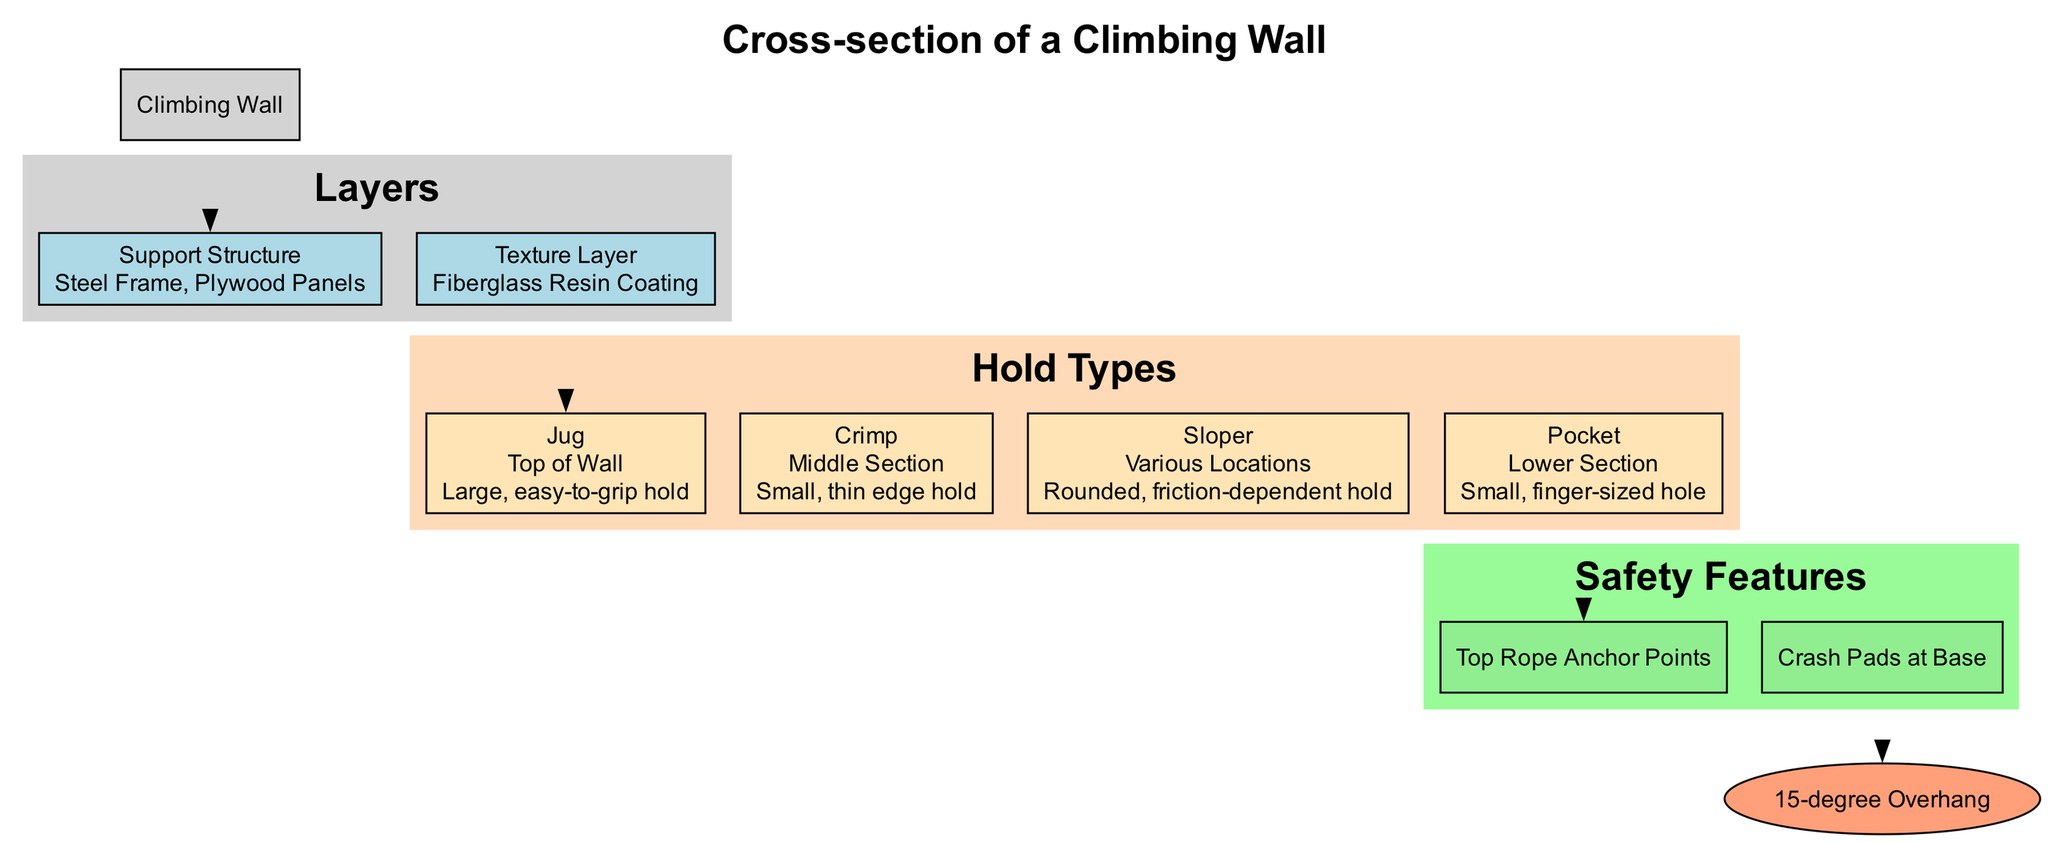What is the main structure of the diagram? The main structure labeled in the diagram is "Climbing Wall." It is represented at the top as the central node which branches out to other components like layers, hold types, and safety features.
Answer: Climbing Wall How many types of climbing holds are there? There are four types of climbing holds indicated in the diagram: Jug, Crimp, Sloper, and Pocket. Each is represented as a separate node under the "Hold Types" section.
Answer: Four What is placed at the top of the climbing wall? The diagram indicates that the type of hold placed at the top of the climbing wall is a "Jug." This is specifically stated in the placement of the Jug hold node.
Answer: Jug Which safety feature is located at the base of the wall? The safety feature shown at the base of the wall in the diagram is "Crash Pads at Base," which is included in the "Safety Features" section.
Answer: Crash Pads at Base What type of hold is described as "rounded, friction-dependent hold"? The hold described with that characteristics is a "Sloper," which is specifically noted in the node detailing the hold types.
Answer: Sloper Where are pocket holds positioned on the wall? According to the diagram, pocket holds are positioned in the "Lower Section" of the climbing wall, as mentioned in the placement description of the Pocket hold node.
Answer: Lower Section What angle does the climbing wall have? The angle of the climbing wall is displayed as "15-degree Overhang." This information is located in the corresponding node that represents the wall angle in the diagram.
Answer: 15-degree Overhang How many components are included in the support structure? The support structure is made up of two components: "Steel Frame" and "Plywood Panels," as indicated in the information about the "Support Structure" layer.
Answer: Two What is the purpose of the Fiberglass Resin Coating? The Fiberglass Resin Coating serves as the "Texture Layer" for the climbing wall, which is aimed at providing grip and protection to the layers beneath it, according to the aspects discussed under layers in the diagram.
Answer: Texture Layer 